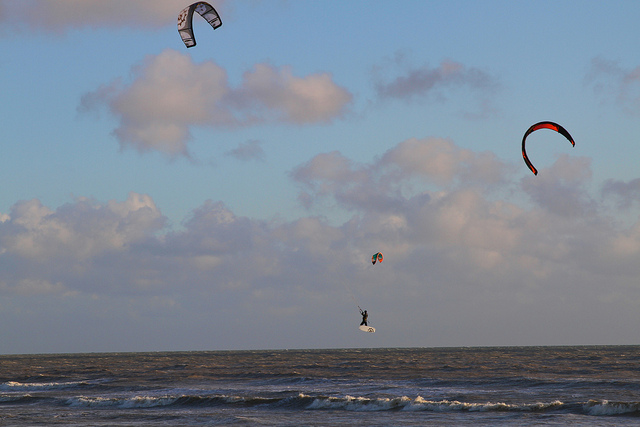Can you describe the emotions this image might evoke in a viewer? This image can stir a sense of awe and inspiration, spurred by the seemingly effortless glide of the kite surfer across the water. The vastness of the sea and the elevation of the kites against the sky may also evoke feelings of freedom and escapism, capturing the viewer's imagination with the boundless possibilities of harnessing the wind. Do you think this activity is accessible to beginners? While the image projects an air of grace and mastery, kite surfing is indeed accessible to beginners, albeit requiring instruction and practice. Starting with safety training and learning to control the kite on land, enthusiasts can gradually build up skills to confidently translate their newfound knowledge to the water—and eventually, perhaps, to scenes such as the one depicted. 